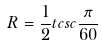<formula> <loc_0><loc_0><loc_500><loc_500>R = \frac { 1 } { 2 } t c s c \frac { \pi } { 6 0 }</formula> 